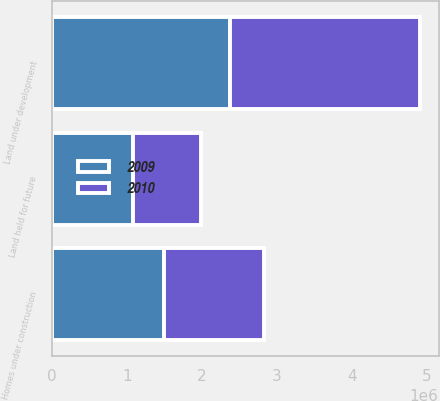Convert chart. <chart><loc_0><loc_0><loc_500><loc_500><stacked_bar_chart><ecel><fcel>Homes under construction<fcel>Land under development<fcel>Land held for future<nl><fcel>2010<fcel>1.33162e+06<fcel>2.54183e+06<fcel>908366<nl><fcel>2009<fcel>1.49289e+06<fcel>2.37088e+06<fcel>1.07659e+06<nl></chart> 